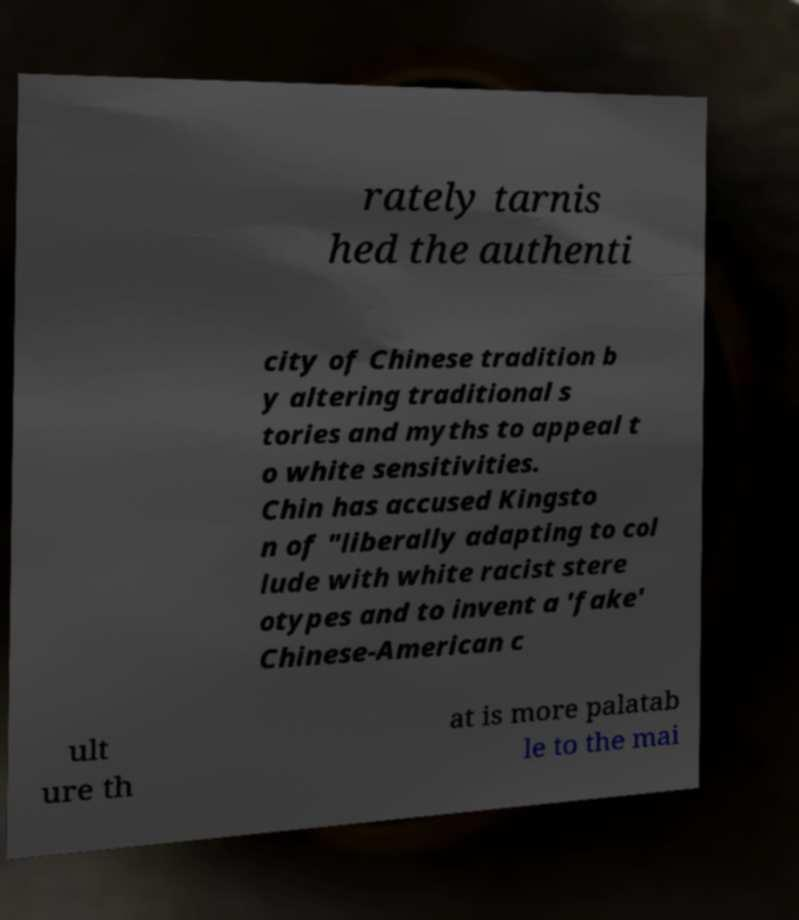Please read and relay the text visible in this image. What does it say? rately tarnis hed the authenti city of Chinese tradition b y altering traditional s tories and myths to appeal t o white sensitivities. Chin has accused Kingsto n of "liberally adapting to col lude with white racist stere otypes and to invent a 'fake' Chinese-American c ult ure th at is more palatab le to the mai 